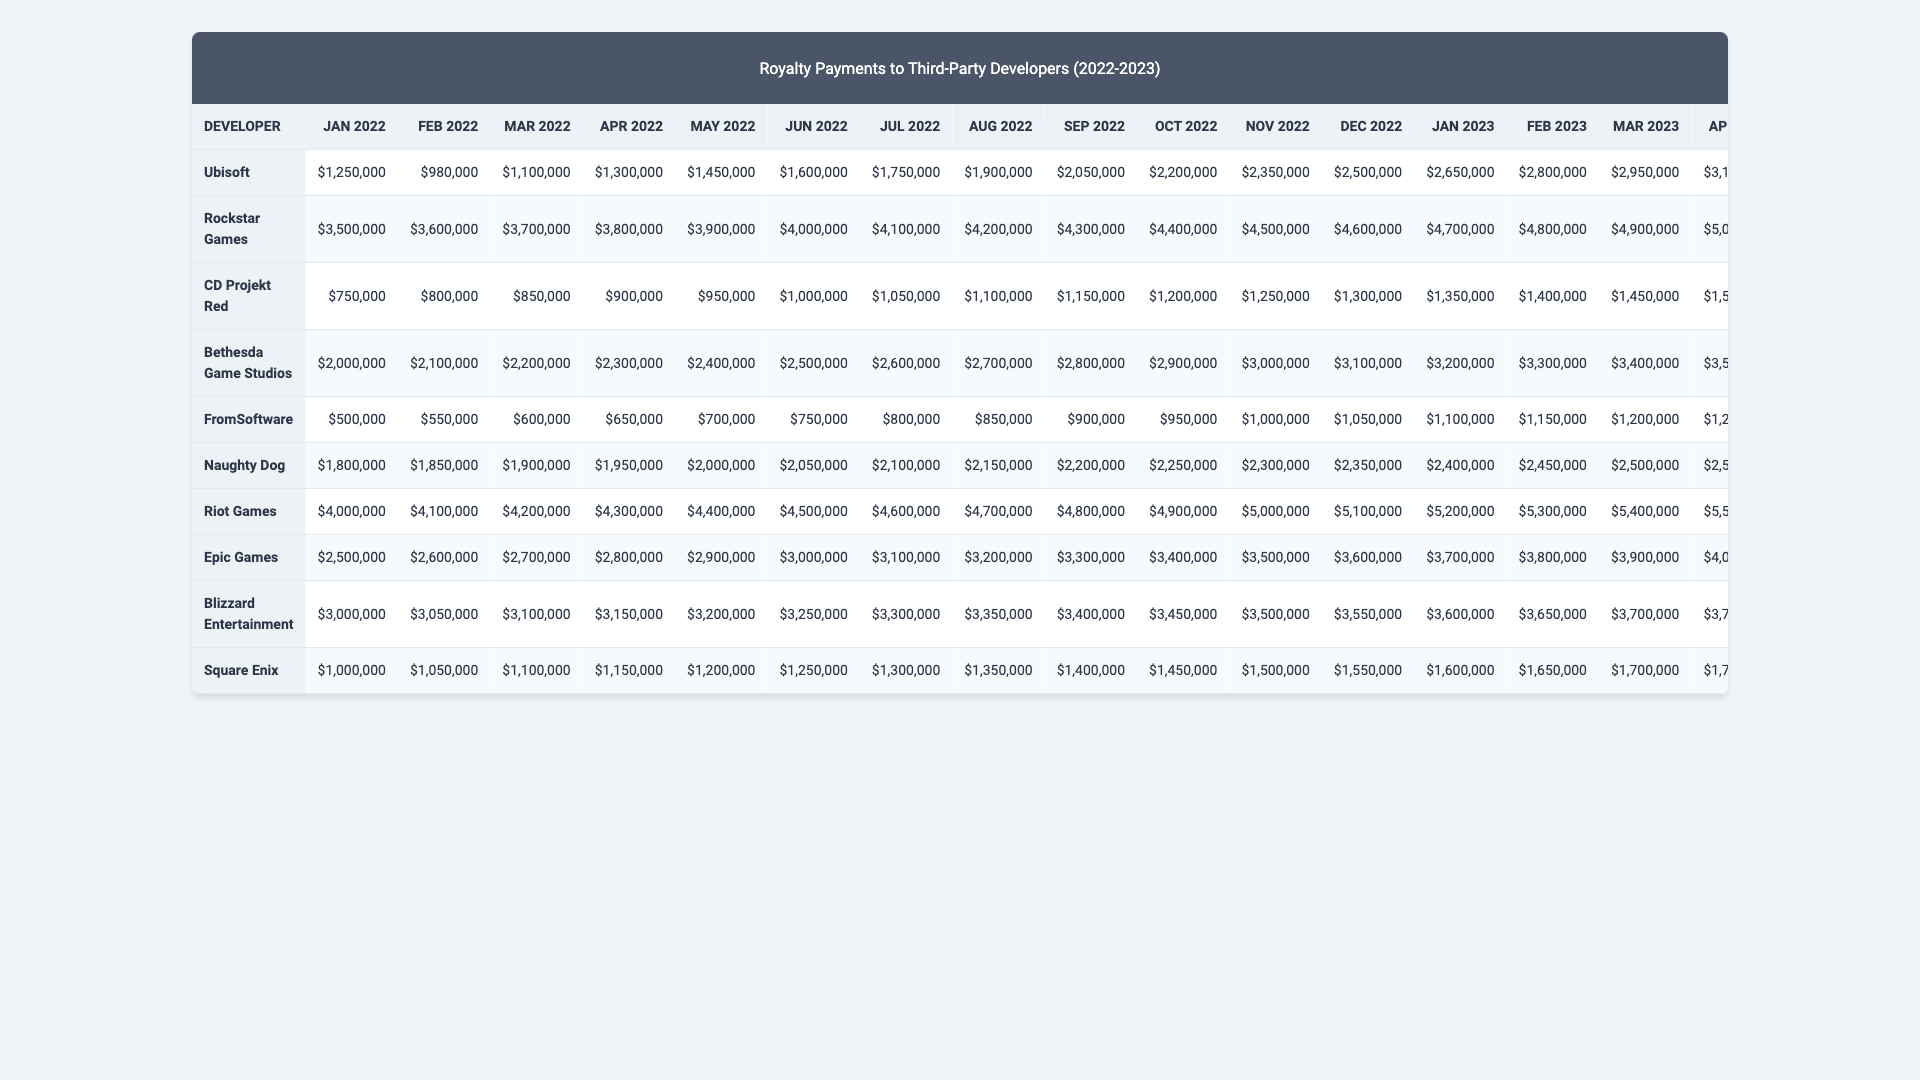What is the highest royalty payment made to a developer in 2023? Looking at the column for each month in 2023, the highest value is in December 2023 at $6,300,000 made to Epic Games.
Answer: $6,300,000 What was the total royalty payment for Naughty Dog over the last 24 months? Summing the values from January 2022 to December 2023 gives: $1,800,000 + $1,850,000 + ... + $2,950,000 = $65,700,000.
Answer: $65,700,000 Did CD Projekt Red ever receive more than $1,500,000 in royalties? Yes, in every month from January 2023 onwards, CD Projekt Red received more than $1,500,000 in royalties.
Answer: Yes Which developer had the most consistent royalty payments across the 24 months? By examining the royalty amounts for each month for developers, FromSoftware shows the least variability in payments, ranging from $500,000 to $1,650,000.
Answer: FromSoftware What is the average monthly payment for Ubisoft across the 24 months? The total payment for Ubisoft over 24 months is $50,550,000, and dividing this by 24 gives an average monthly payment of $2,103,125.
Answer: $2,103,125 Which developer received payments only below $1,000,000 for the first six months of 2022? Only FromSoftware received royalty payments below $1,000,000 for all months from January to June 2022.
Answer: FromSoftware What is the difference in total royalty payments between Square Enix and Blizzard Entertainment for 2023? Square Enix received a total of $45,835,000 while Blizzard Entertainment received $67,720,000 in 2023. The difference is $67,720,000 - $45,835,000 = $21,885,000.
Answer: $21,885,000 How did the royalty payments to Riot Games change from January 2022 to December 2023? Riot Games saw an increase from $2,500,000 in January 2022 to $4,800,000 in December 2023, indicating a consistent upward trend.
Answer: Increased What was the average royalty payment for Bethesda Game Studios during 2022? The monthly payments for Bethesda in 2022 are summed and then divided by 12. The total is $34,800,000, and the average is $2,900,000.
Answer: $2,900,000 Did any developer receive the same amount in royalties for any two months during 2023? Yes, both Riot Games and Square Enix received $5,600,000 in June 2023 and $5,700,000 in July 2023.
Answer: Yes 